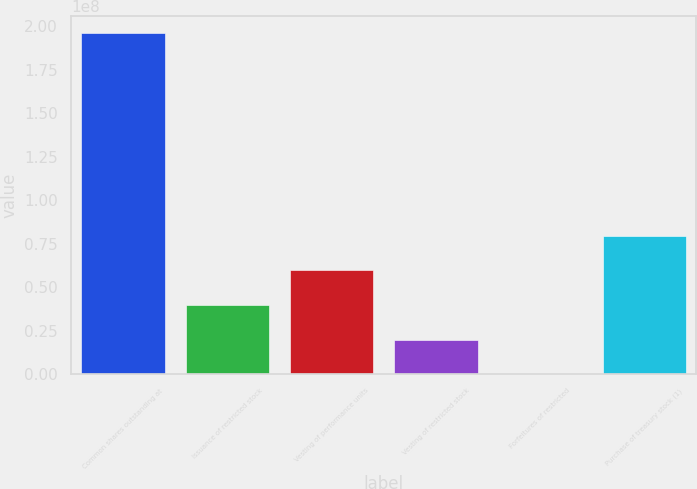<chart> <loc_0><loc_0><loc_500><loc_500><bar_chart><fcel>Common shares outstanding at<fcel>Issuance of restricted stock<fcel>Vesting of performance units<fcel>Vesting of restricted stock<fcel>Forfeitures of restricted<fcel>Purchase of treasury stock (1)<nl><fcel>1.96086e+08<fcel>3.9827e+07<fcel>5.97024e+07<fcel>1.99515e+07<fcel>76107<fcel>7.95778e+07<nl></chart> 